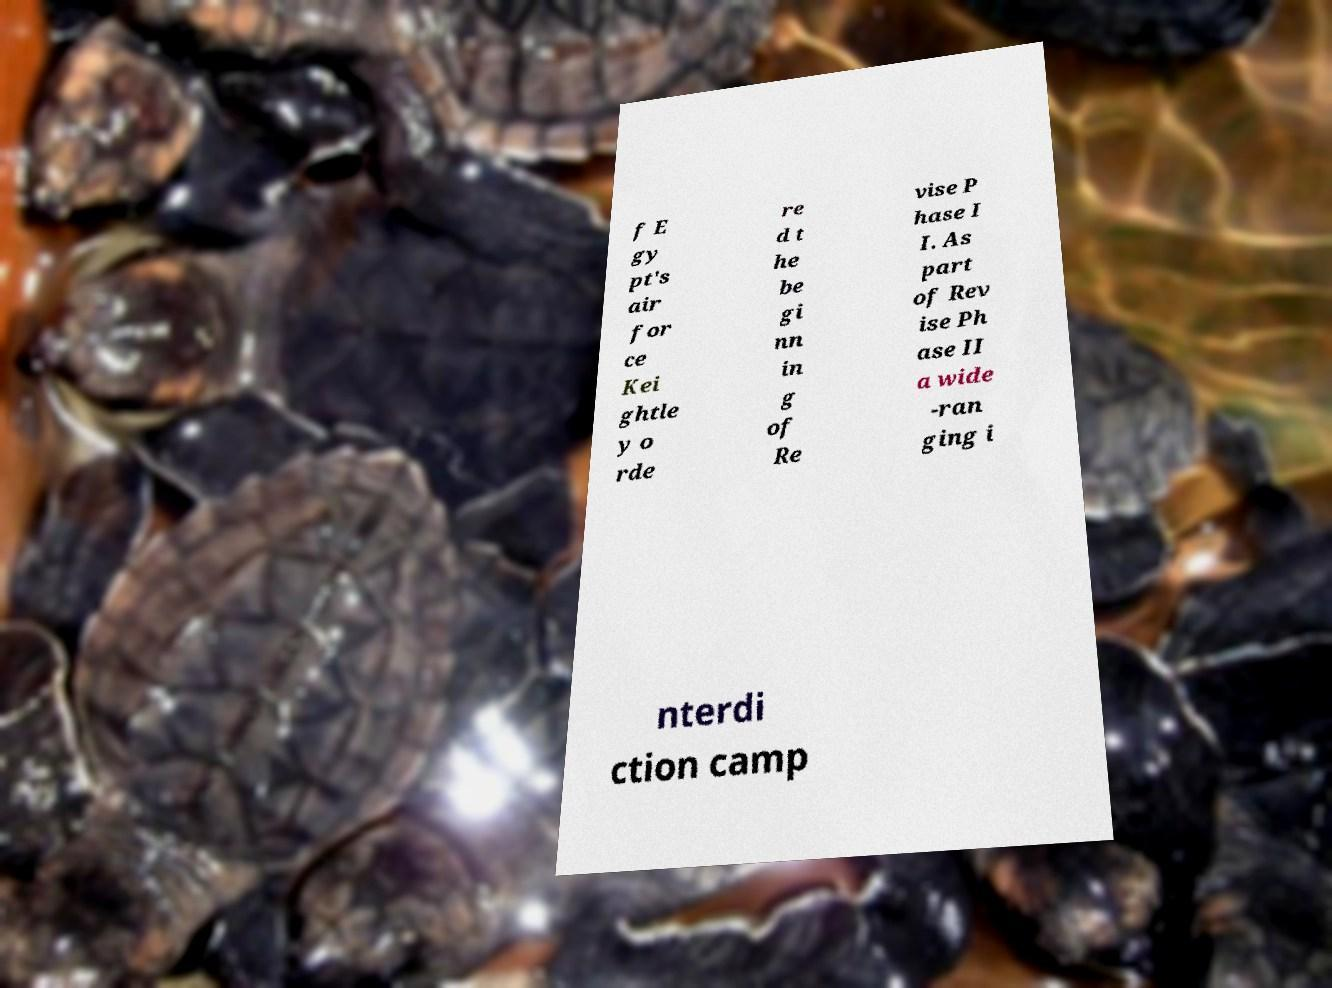Could you assist in decoding the text presented in this image and type it out clearly? f E gy pt's air for ce Kei ghtle y o rde re d t he be gi nn in g of Re vise P hase I I. As part of Rev ise Ph ase II a wide -ran ging i nterdi ction camp 